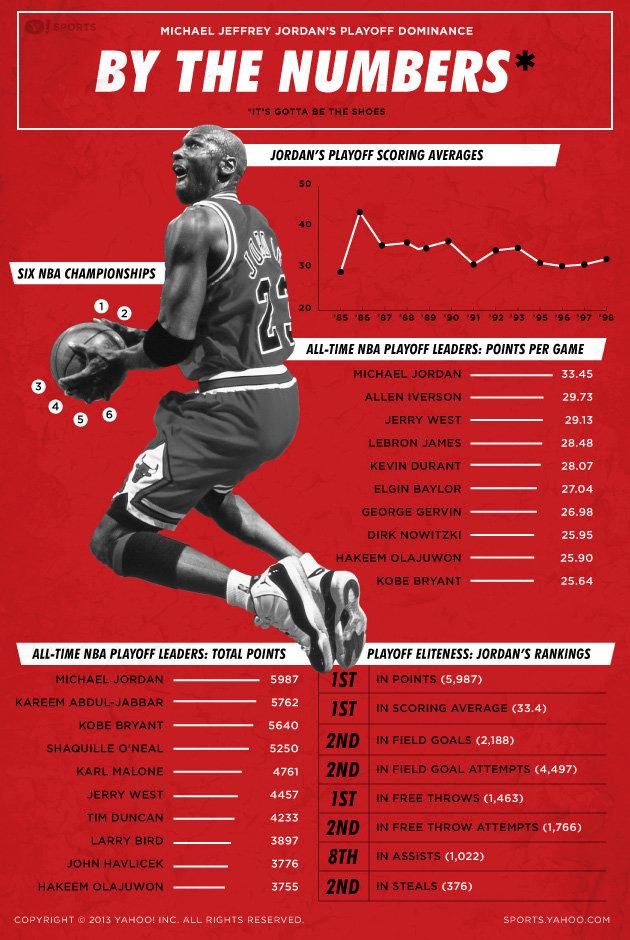Outline some significant characteristics in this image. The person who has won six NBA championships is Michael Jordan. 